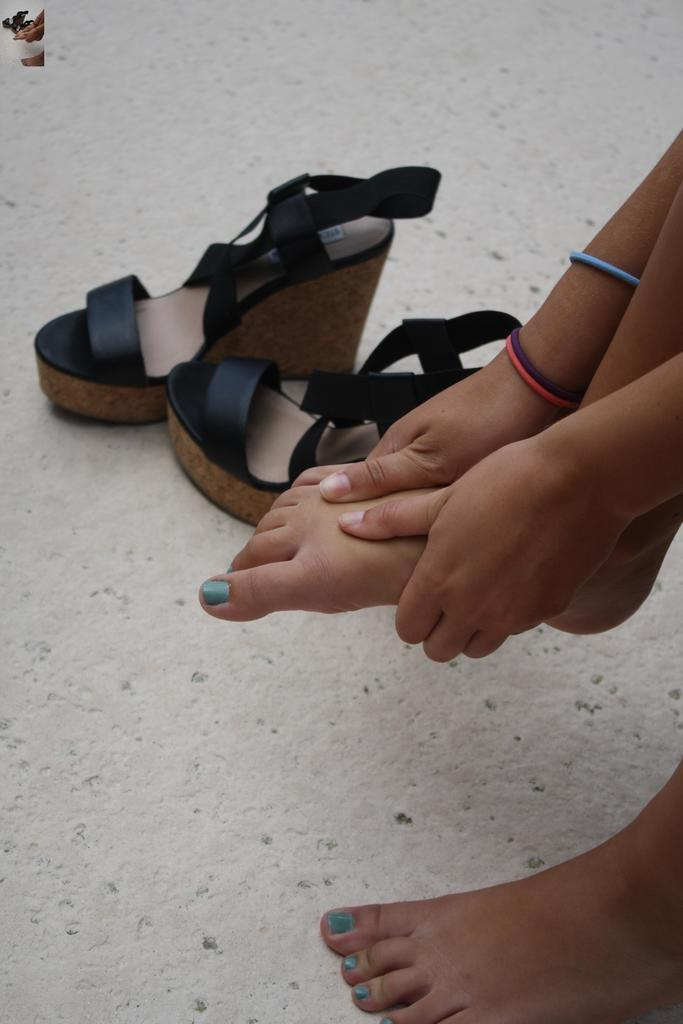What is the main subject of the image? There is a person in the image. What is the person doing with their hands? The person's hands are holding one of their legs. What type of footwear is visible in the image? There is a pair of sandals beside the person's legs. What type of celery is being used as a prop in the image? There is no celery present in the image. How many cabbages can be seen in the background of the image? There are no cabbages visible in the image. 